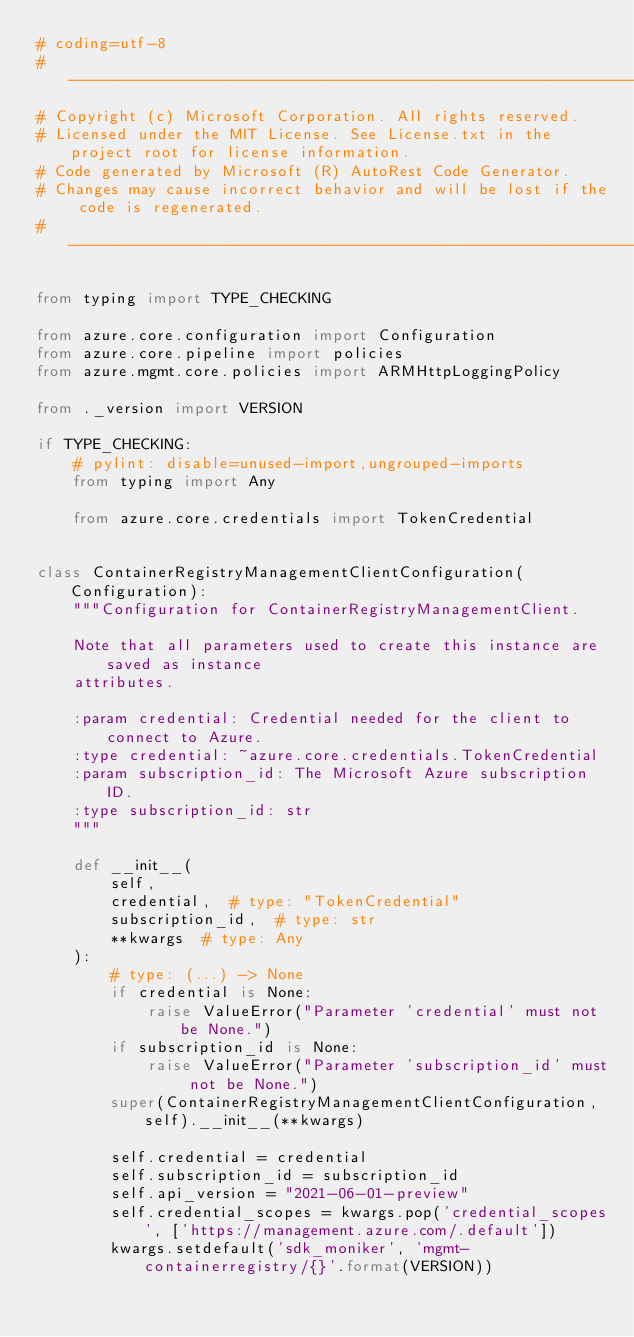<code> <loc_0><loc_0><loc_500><loc_500><_Python_># coding=utf-8
# --------------------------------------------------------------------------
# Copyright (c) Microsoft Corporation. All rights reserved.
# Licensed under the MIT License. See License.txt in the project root for license information.
# Code generated by Microsoft (R) AutoRest Code Generator.
# Changes may cause incorrect behavior and will be lost if the code is regenerated.
# --------------------------------------------------------------------------

from typing import TYPE_CHECKING

from azure.core.configuration import Configuration
from azure.core.pipeline import policies
from azure.mgmt.core.policies import ARMHttpLoggingPolicy

from ._version import VERSION

if TYPE_CHECKING:
    # pylint: disable=unused-import,ungrouped-imports
    from typing import Any

    from azure.core.credentials import TokenCredential


class ContainerRegistryManagementClientConfiguration(Configuration):
    """Configuration for ContainerRegistryManagementClient.

    Note that all parameters used to create this instance are saved as instance
    attributes.

    :param credential: Credential needed for the client to connect to Azure.
    :type credential: ~azure.core.credentials.TokenCredential
    :param subscription_id: The Microsoft Azure subscription ID.
    :type subscription_id: str
    """

    def __init__(
        self,
        credential,  # type: "TokenCredential"
        subscription_id,  # type: str
        **kwargs  # type: Any
    ):
        # type: (...) -> None
        if credential is None:
            raise ValueError("Parameter 'credential' must not be None.")
        if subscription_id is None:
            raise ValueError("Parameter 'subscription_id' must not be None.")
        super(ContainerRegistryManagementClientConfiguration, self).__init__(**kwargs)

        self.credential = credential
        self.subscription_id = subscription_id
        self.api_version = "2021-06-01-preview"
        self.credential_scopes = kwargs.pop('credential_scopes', ['https://management.azure.com/.default'])
        kwargs.setdefault('sdk_moniker', 'mgmt-containerregistry/{}'.format(VERSION))</code> 